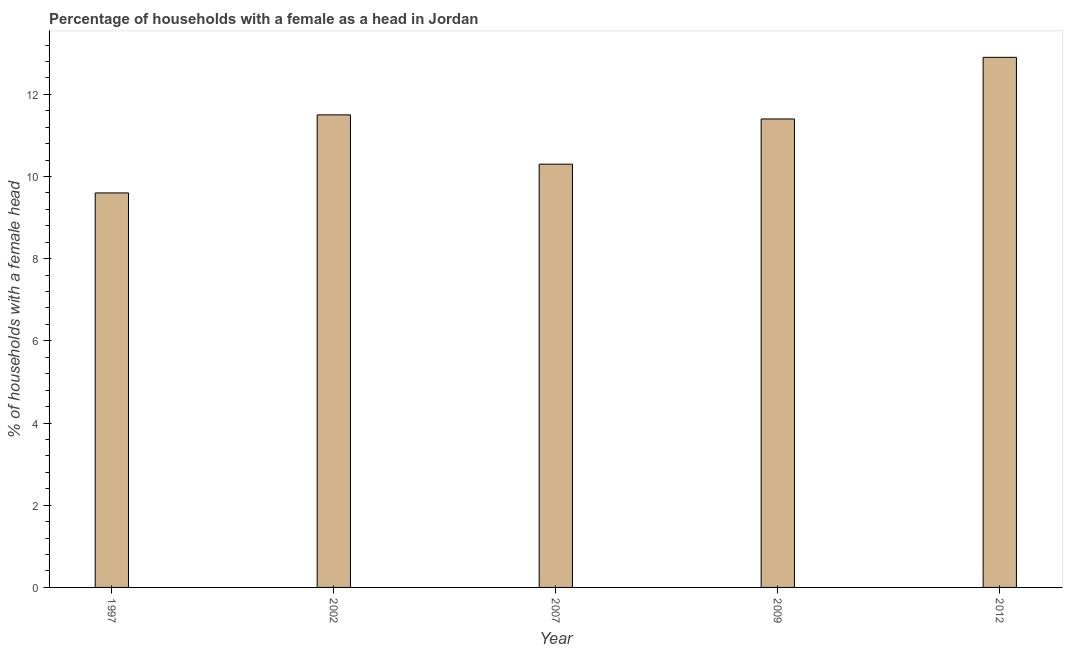Does the graph contain any zero values?
Give a very brief answer. No. What is the title of the graph?
Ensure brevity in your answer.  Percentage of households with a female as a head in Jordan. What is the label or title of the Y-axis?
Make the answer very short. % of households with a female head. What is the number of female supervised households in 2009?
Provide a succinct answer. 11.4. Across all years, what is the maximum number of female supervised households?
Provide a succinct answer. 12.9. Across all years, what is the minimum number of female supervised households?
Keep it short and to the point. 9.6. In which year was the number of female supervised households minimum?
Your answer should be very brief. 1997. What is the sum of the number of female supervised households?
Provide a short and direct response. 55.7. What is the difference between the number of female supervised households in 2002 and 2009?
Give a very brief answer. 0.1. What is the average number of female supervised households per year?
Offer a very short reply. 11.14. In how many years, is the number of female supervised households greater than 3.6 %?
Make the answer very short. 5. Do a majority of the years between 2009 and 2007 (inclusive) have number of female supervised households greater than 5.6 %?
Your answer should be compact. No. What is the ratio of the number of female supervised households in 2009 to that in 2012?
Your answer should be compact. 0.88. Is the number of female supervised households in 2007 less than that in 2009?
Ensure brevity in your answer.  Yes. What is the difference between the highest and the second highest number of female supervised households?
Make the answer very short. 1.4. Is the sum of the number of female supervised households in 2007 and 2012 greater than the maximum number of female supervised households across all years?
Make the answer very short. Yes. In how many years, is the number of female supervised households greater than the average number of female supervised households taken over all years?
Offer a very short reply. 3. How many bars are there?
Give a very brief answer. 5. What is the difference between two consecutive major ticks on the Y-axis?
Ensure brevity in your answer.  2. What is the % of households with a female head of 2002?
Ensure brevity in your answer.  11.5. What is the % of households with a female head of 2007?
Give a very brief answer. 10.3. What is the % of households with a female head of 2012?
Your answer should be very brief. 12.9. What is the difference between the % of households with a female head in 1997 and 2007?
Keep it short and to the point. -0.7. What is the difference between the % of households with a female head in 1997 and 2009?
Your response must be concise. -1.8. What is the difference between the % of households with a female head in 2002 and 2007?
Provide a short and direct response. 1.2. What is the ratio of the % of households with a female head in 1997 to that in 2002?
Your answer should be compact. 0.83. What is the ratio of the % of households with a female head in 1997 to that in 2007?
Your response must be concise. 0.93. What is the ratio of the % of households with a female head in 1997 to that in 2009?
Give a very brief answer. 0.84. What is the ratio of the % of households with a female head in 1997 to that in 2012?
Provide a short and direct response. 0.74. What is the ratio of the % of households with a female head in 2002 to that in 2007?
Give a very brief answer. 1.12. What is the ratio of the % of households with a female head in 2002 to that in 2009?
Give a very brief answer. 1.01. What is the ratio of the % of households with a female head in 2002 to that in 2012?
Your answer should be very brief. 0.89. What is the ratio of the % of households with a female head in 2007 to that in 2009?
Provide a succinct answer. 0.9. What is the ratio of the % of households with a female head in 2007 to that in 2012?
Make the answer very short. 0.8. What is the ratio of the % of households with a female head in 2009 to that in 2012?
Your response must be concise. 0.88. 